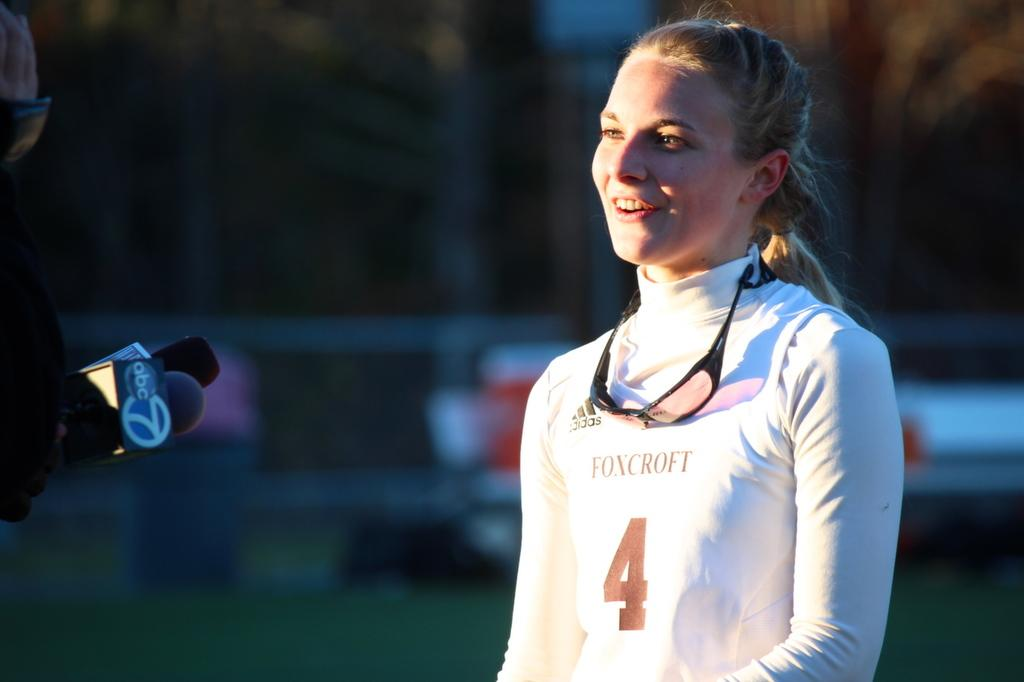Who is present in the image? There is a person in the image. What is the person wearing? The person is wearing a white dress. What objects are in front of the person? There are microphones (mics) in front of the person. Can you describe the background of the image? The background of the image is blurred. How many flowers can be seen on the person's toes in the image? There are no flowers or toes visible in the image; it features a person wearing a white dress with microphones in front of them. 